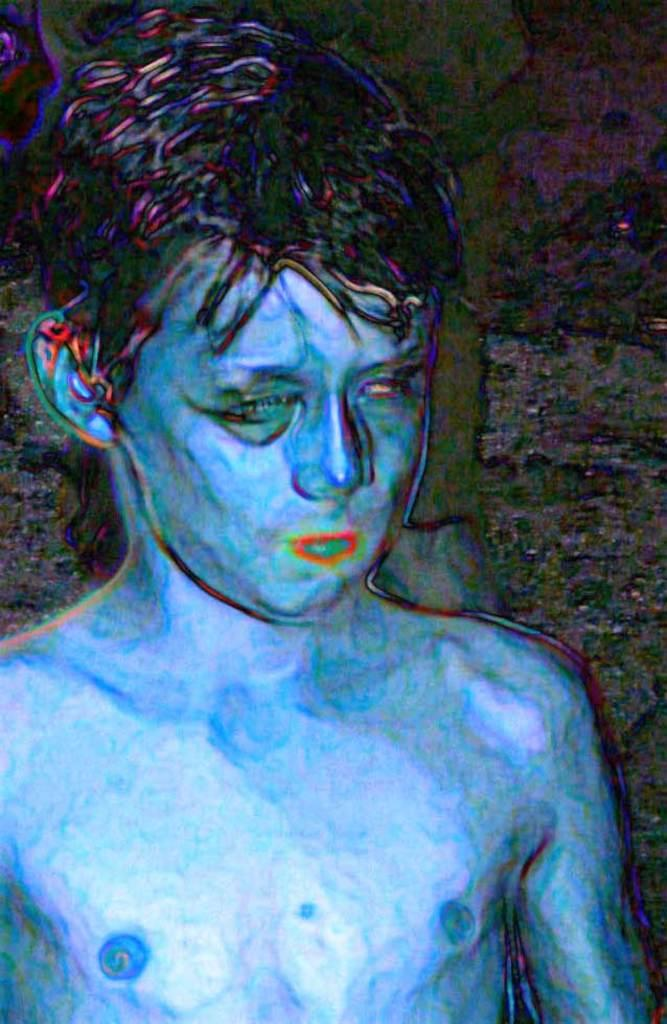What is the main subject of the image? There is a boy in the image. Can you describe any characteristics of the image? The image appears to be edited. What type of sack is the boy carrying in the image? There is no sack present in the image; the boy is not carrying anything. What is the boy using to make tea in the image? There is no kettle or tea-making activity present in the image. 